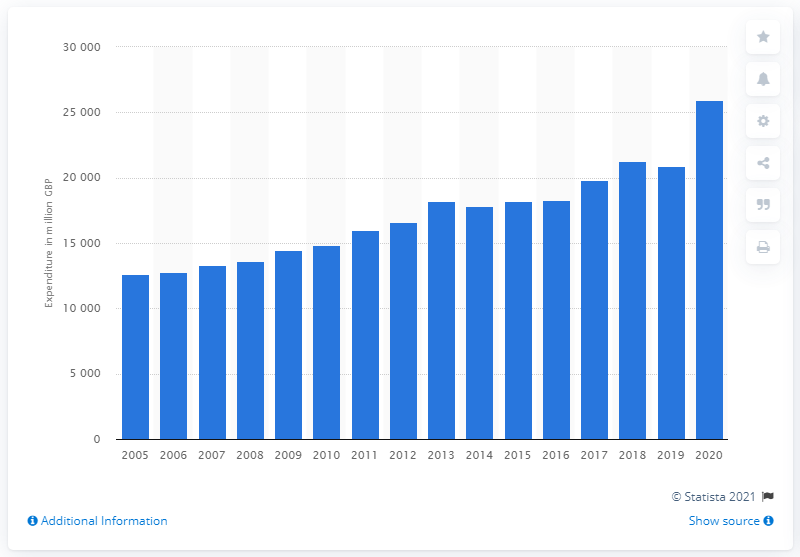Are there any noticeable fluctuations in spending depicted on this chart? Observing the chart, while the general direction is upward, there are certain years where spending plateaus or slightly decreases before continuing its ascent. For instance, the spending appears relatively constant around 2009, which may correlate with economic events such as the financial crisis impacting consumer spending habits. 